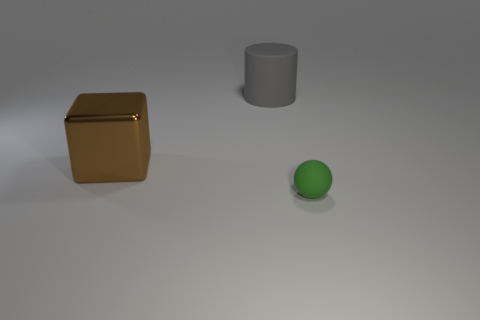Are there any other things that are the same shape as the tiny green matte thing?
Provide a short and direct response. No. What shape is the brown metal thing that is the same size as the cylinder?
Ensure brevity in your answer.  Cube. What size is the object that is in front of the large matte thing and behind the green thing?
Provide a short and direct response. Large. What number of metal objects are large red cylinders or small green things?
Your answer should be very brief. 0. Are there more objects left of the tiny rubber ball than blue metal cylinders?
Give a very brief answer. Yes. There is a thing that is in front of the big shiny cube; what is its material?
Your answer should be very brief. Rubber. What number of brown objects are the same material as the block?
Offer a very short reply. 0. There is a thing that is to the right of the big brown object and in front of the large cylinder; what shape is it?
Ensure brevity in your answer.  Sphere. How many objects are rubber objects that are behind the big brown metal thing or objects behind the green rubber sphere?
Ensure brevity in your answer.  2. Are there an equal number of large rubber cylinders in front of the big cylinder and big things on the right side of the block?
Ensure brevity in your answer.  No. 